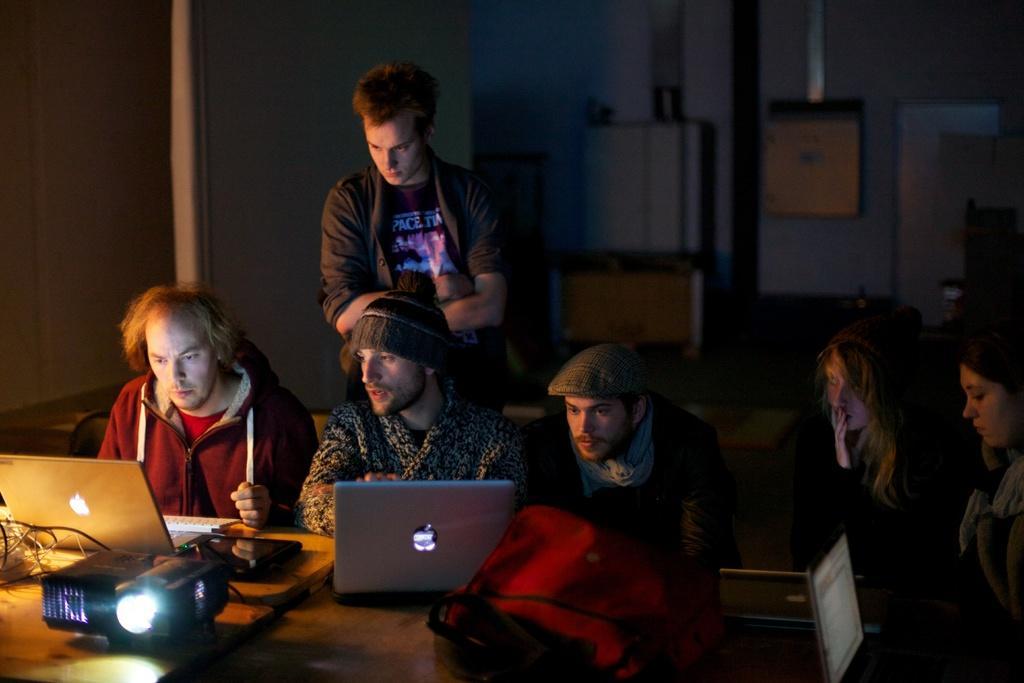Could you give a brief overview of what you see in this image? In this image in the front there is a table, on the table there are laptops, wires and there is a bag and a projector. In the center there are persons sitting and there is a man standing. In the background there are objects which are visible. 